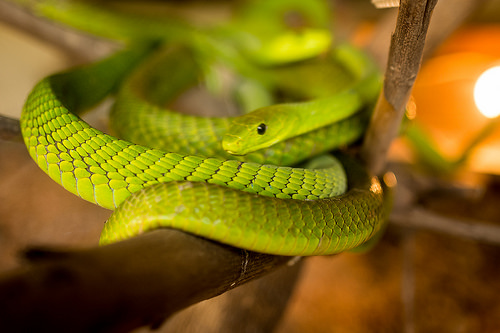<image>
Can you confirm if the snake is next to the tree branch? Yes. The snake is positioned adjacent to the tree branch, located nearby in the same general area. Where is the snake in relation to the wood? Is it above the wood? Yes. The snake is positioned above the wood in the vertical space, higher up in the scene. 